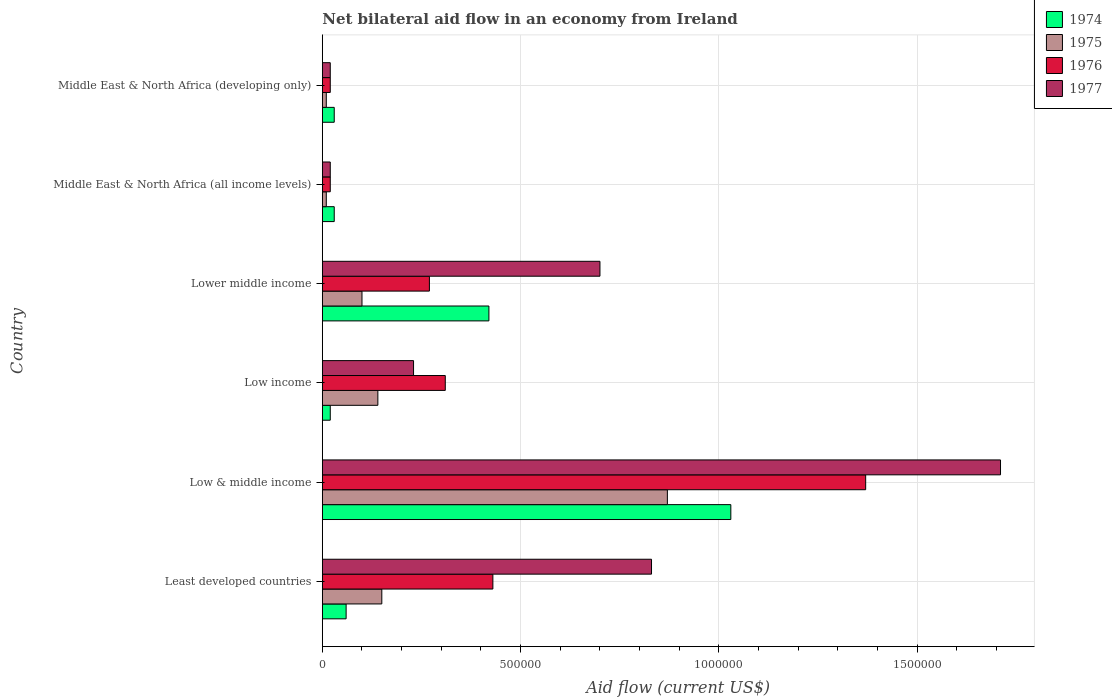How many different coloured bars are there?
Offer a very short reply. 4. How many groups of bars are there?
Make the answer very short. 6. What is the label of the 2nd group of bars from the top?
Offer a very short reply. Middle East & North Africa (all income levels). What is the net bilateral aid flow in 1975 in Lower middle income?
Make the answer very short. 1.00e+05. Across all countries, what is the maximum net bilateral aid flow in 1977?
Keep it short and to the point. 1.71e+06. Across all countries, what is the minimum net bilateral aid flow in 1975?
Your answer should be very brief. 10000. In which country was the net bilateral aid flow in 1975 minimum?
Your answer should be very brief. Middle East & North Africa (all income levels). What is the total net bilateral aid flow in 1977 in the graph?
Your response must be concise. 3.51e+06. What is the difference between the net bilateral aid flow in 1974 in Low income and that in Lower middle income?
Provide a succinct answer. -4.00e+05. What is the average net bilateral aid flow in 1976 per country?
Ensure brevity in your answer.  4.03e+05. Is the net bilateral aid flow in 1975 in Least developed countries less than that in Middle East & North Africa (all income levels)?
Your answer should be compact. No. What is the difference between the highest and the second highest net bilateral aid flow in 1974?
Give a very brief answer. 6.10e+05. What is the difference between the highest and the lowest net bilateral aid flow in 1977?
Provide a succinct answer. 1.69e+06. Is the sum of the net bilateral aid flow in 1975 in Low & middle income and Middle East & North Africa (developing only) greater than the maximum net bilateral aid flow in 1977 across all countries?
Provide a short and direct response. No. Is it the case that in every country, the sum of the net bilateral aid flow in 1976 and net bilateral aid flow in 1977 is greater than the sum of net bilateral aid flow in 1974 and net bilateral aid flow in 1975?
Provide a short and direct response. No. What does the 3rd bar from the top in Lower middle income represents?
Your answer should be compact. 1975. What does the 3rd bar from the bottom in Low income represents?
Your answer should be very brief. 1976. How many bars are there?
Provide a short and direct response. 24. Are all the bars in the graph horizontal?
Make the answer very short. Yes. How many countries are there in the graph?
Your response must be concise. 6. Does the graph contain any zero values?
Offer a terse response. No. Does the graph contain grids?
Ensure brevity in your answer.  Yes. Where does the legend appear in the graph?
Your answer should be compact. Top right. How many legend labels are there?
Keep it short and to the point. 4. What is the title of the graph?
Offer a very short reply. Net bilateral aid flow in an economy from Ireland. Does "2001" appear as one of the legend labels in the graph?
Your answer should be very brief. No. What is the Aid flow (current US$) in 1974 in Least developed countries?
Provide a short and direct response. 6.00e+04. What is the Aid flow (current US$) in 1976 in Least developed countries?
Ensure brevity in your answer.  4.30e+05. What is the Aid flow (current US$) of 1977 in Least developed countries?
Make the answer very short. 8.30e+05. What is the Aid flow (current US$) in 1974 in Low & middle income?
Offer a very short reply. 1.03e+06. What is the Aid flow (current US$) of 1975 in Low & middle income?
Offer a terse response. 8.70e+05. What is the Aid flow (current US$) in 1976 in Low & middle income?
Provide a short and direct response. 1.37e+06. What is the Aid flow (current US$) of 1977 in Low & middle income?
Your answer should be very brief. 1.71e+06. What is the Aid flow (current US$) of 1975 in Low income?
Your answer should be compact. 1.40e+05. What is the Aid flow (current US$) of 1976 in Low income?
Provide a short and direct response. 3.10e+05. What is the Aid flow (current US$) of 1974 in Lower middle income?
Ensure brevity in your answer.  4.20e+05. What is the Aid flow (current US$) in 1975 in Lower middle income?
Provide a short and direct response. 1.00e+05. What is the Aid flow (current US$) of 1976 in Lower middle income?
Your answer should be compact. 2.70e+05. What is the Aid flow (current US$) in 1975 in Middle East & North Africa (all income levels)?
Make the answer very short. 10000. What is the Aid flow (current US$) in 1974 in Middle East & North Africa (developing only)?
Your answer should be very brief. 3.00e+04. What is the Aid flow (current US$) of 1975 in Middle East & North Africa (developing only)?
Make the answer very short. 10000. What is the Aid flow (current US$) of 1976 in Middle East & North Africa (developing only)?
Keep it short and to the point. 2.00e+04. Across all countries, what is the maximum Aid flow (current US$) of 1974?
Keep it short and to the point. 1.03e+06. Across all countries, what is the maximum Aid flow (current US$) of 1975?
Give a very brief answer. 8.70e+05. Across all countries, what is the maximum Aid flow (current US$) in 1976?
Provide a succinct answer. 1.37e+06. Across all countries, what is the maximum Aid flow (current US$) of 1977?
Keep it short and to the point. 1.71e+06. Across all countries, what is the minimum Aid flow (current US$) in 1974?
Keep it short and to the point. 2.00e+04. Across all countries, what is the minimum Aid flow (current US$) of 1975?
Give a very brief answer. 10000. Across all countries, what is the minimum Aid flow (current US$) in 1977?
Your answer should be compact. 2.00e+04. What is the total Aid flow (current US$) of 1974 in the graph?
Offer a very short reply. 1.59e+06. What is the total Aid flow (current US$) in 1975 in the graph?
Offer a very short reply. 1.28e+06. What is the total Aid flow (current US$) in 1976 in the graph?
Make the answer very short. 2.42e+06. What is the total Aid flow (current US$) in 1977 in the graph?
Ensure brevity in your answer.  3.51e+06. What is the difference between the Aid flow (current US$) of 1974 in Least developed countries and that in Low & middle income?
Offer a very short reply. -9.70e+05. What is the difference between the Aid flow (current US$) of 1975 in Least developed countries and that in Low & middle income?
Provide a succinct answer. -7.20e+05. What is the difference between the Aid flow (current US$) in 1976 in Least developed countries and that in Low & middle income?
Provide a succinct answer. -9.40e+05. What is the difference between the Aid flow (current US$) in 1977 in Least developed countries and that in Low & middle income?
Your response must be concise. -8.80e+05. What is the difference between the Aid flow (current US$) in 1974 in Least developed countries and that in Low income?
Offer a terse response. 4.00e+04. What is the difference between the Aid flow (current US$) of 1975 in Least developed countries and that in Low income?
Your answer should be very brief. 10000. What is the difference between the Aid flow (current US$) in 1977 in Least developed countries and that in Low income?
Your response must be concise. 6.00e+05. What is the difference between the Aid flow (current US$) in 1974 in Least developed countries and that in Lower middle income?
Your answer should be compact. -3.60e+05. What is the difference between the Aid flow (current US$) in 1976 in Least developed countries and that in Lower middle income?
Offer a very short reply. 1.60e+05. What is the difference between the Aid flow (current US$) in 1974 in Least developed countries and that in Middle East & North Africa (all income levels)?
Give a very brief answer. 3.00e+04. What is the difference between the Aid flow (current US$) in 1975 in Least developed countries and that in Middle East & North Africa (all income levels)?
Your answer should be very brief. 1.40e+05. What is the difference between the Aid flow (current US$) in 1976 in Least developed countries and that in Middle East & North Africa (all income levels)?
Offer a terse response. 4.10e+05. What is the difference between the Aid flow (current US$) of 1977 in Least developed countries and that in Middle East & North Africa (all income levels)?
Make the answer very short. 8.10e+05. What is the difference between the Aid flow (current US$) in 1974 in Least developed countries and that in Middle East & North Africa (developing only)?
Ensure brevity in your answer.  3.00e+04. What is the difference between the Aid flow (current US$) of 1975 in Least developed countries and that in Middle East & North Africa (developing only)?
Give a very brief answer. 1.40e+05. What is the difference between the Aid flow (current US$) in 1976 in Least developed countries and that in Middle East & North Africa (developing only)?
Provide a succinct answer. 4.10e+05. What is the difference between the Aid flow (current US$) of 1977 in Least developed countries and that in Middle East & North Africa (developing only)?
Give a very brief answer. 8.10e+05. What is the difference between the Aid flow (current US$) of 1974 in Low & middle income and that in Low income?
Your answer should be compact. 1.01e+06. What is the difference between the Aid flow (current US$) in 1975 in Low & middle income and that in Low income?
Make the answer very short. 7.30e+05. What is the difference between the Aid flow (current US$) in 1976 in Low & middle income and that in Low income?
Your response must be concise. 1.06e+06. What is the difference between the Aid flow (current US$) in 1977 in Low & middle income and that in Low income?
Your answer should be very brief. 1.48e+06. What is the difference between the Aid flow (current US$) in 1974 in Low & middle income and that in Lower middle income?
Make the answer very short. 6.10e+05. What is the difference between the Aid flow (current US$) of 1975 in Low & middle income and that in Lower middle income?
Your answer should be very brief. 7.70e+05. What is the difference between the Aid flow (current US$) of 1976 in Low & middle income and that in Lower middle income?
Your answer should be compact. 1.10e+06. What is the difference between the Aid flow (current US$) in 1977 in Low & middle income and that in Lower middle income?
Your answer should be very brief. 1.01e+06. What is the difference between the Aid flow (current US$) in 1974 in Low & middle income and that in Middle East & North Africa (all income levels)?
Provide a succinct answer. 1.00e+06. What is the difference between the Aid flow (current US$) in 1975 in Low & middle income and that in Middle East & North Africa (all income levels)?
Your answer should be very brief. 8.60e+05. What is the difference between the Aid flow (current US$) in 1976 in Low & middle income and that in Middle East & North Africa (all income levels)?
Your answer should be compact. 1.35e+06. What is the difference between the Aid flow (current US$) of 1977 in Low & middle income and that in Middle East & North Africa (all income levels)?
Offer a terse response. 1.69e+06. What is the difference between the Aid flow (current US$) of 1975 in Low & middle income and that in Middle East & North Africa (developing only)?
Your answer should be very brief. 8.60e+05. What is the difference between the Aid flow (current US$) of 1976 in Low & middle income and that in Middle East & North Africa (developing only)?
Your answer should be very brief. 1.35e+06. What is the difference between the Aid flow (current US$) in 1977 in Low & middle income and that in Middle East & North Africa (developing only)?
Offer a terse response. 1.69e+06. What is the difference between the Aid flow (current US$) in 1974 in Low income and that in Lower middle income?
Ensure brevity in your answer.  -4.00e+05. What is the difference between the Aid flow (current US$) of 1977 in Low income and that in Lower middle income?
Make the answer very short. -4.70e+05. What is the difference between the Aid flow (current US$) of 1975 in Low income and that in Middle East & North Africa (all income levels)?
Keep it short and to the point. 1.30e+05. What is the difference between the Aid flow (current US$) in 1976 in Low income and that in Middle East & North Africa (all income levels)?
Your answer should be very brief. 2.90e+05. What is the difference between the Aid flow (current US$) in 1977 in Low income and that in Middle East & North Africa (all income levels)?
Your response must be concise. 2.10e+05. What is the difference between the Aid flow (current US$) in 1974 in Low income and that in Middle East & North Africa (developing only)?
Your response must be concise. -10000. What is the difference between the Aid flow (current US$) of 1975 in Low income and that in Middle East & North Africa (developing only)?
Offer a terse response. 1.30e+05. What is the difference between the Aid flow (current US$) in 1976 in Low income and that in Middle East & North Africa (developing only)?
Ensure brevity in your answer.  2.90e+05. What is the difference between the Aid flow (current US$) in 1977 in Low income and that in Middle East & North Africa (developing only)?
Provide a short and direct response. 2.10e+05. What is the difference between the Aid flow (current US$) in 1974 in Lower middle income and that in Middle East & North Africa (all income levels)?
Your answer should be compact. 3.90e+05. What is the difference between the Aid flow (current US$) in 1975 in Lower middle income and that in Middle East & North Africa (all income levels)?
Keep it short and to the point. 9.00e+04. What is the difference between the Aid flow (current US$) of 1977 in Lower middle income and that in Middle East & North Africa (all income levels)?
Provide a succinct answer. 6.80e+05. What is the difference between the Aid flow (current US$) of 1975 in Lower middle income and that in Middle East & North Africa (developing only)?
Your response must be concise. 9.00e+04. What is the difference between the Aid flow (current US$) of 1976 in Lower middle income and that in Middle East & North Africa (developing only)?
Your response must be concise. 2.50e+05. What is the difference between the Aid flow (current US$) of 1977 in Lower middle income and that in Middle East & North Africa (developing only)?
Your answer should be very brief. 6.80e+05. What is the difference between the Aid flow (current US$) in 1975 in Middle East & North Africa (all income levels) and that in Middle East & North Africa (developing only)?
Your answer should be very brief. 0. What is the difference between the Aid flow (current US$) of 1976 in Middle East & North Africa (all income levels) and that in Middle East & North Africa (developing only)?
Make the answer very short. 0. What is the difference between the Aid flow (current US$) of 1974 in Least developed countries and the Aid flow (current US$) of 1975 in Low & middle income?
Your answer should be very brief. -8.10e+05. What is the difference between the Aid flow (current US$) of 1974 in Least developed countries and the Aid flow (current US$) of 1976 in Low & middle income?
Provide a succinct answer. -1.31e+06. What is the difference between the Aid flow (current US$) in 1974 in Least developed countries and the Aid flow (current US$) in 1977 in Low & middle income?
Provide a short and direct response. -1.65e+06. What is the difference between the Aid flow (current US$) in 1975 in Least developed countries and the Aid flow (current US$) in 1976 in Low & middle income?
Keep it short and to the point. -1.22e+06. What is the difference between the Aid flow (current US$) in 1975 in Least developed countries and the Aid flow (current US$) in 1977 in Low & middle income?
Give a very brief answer. -1.56e+06. What is the difference between the Aid flow (current US$) of 1976 in Least developed countries and the Aid flow (current US$) of 1977 in Low & middle income?
Your answer should be very brief. -1.28e+06. What is the difference between the Aid flow (current US$) of 1974 in Least developed countries and the Aid flow (current US$) of 1975 in Low income?
Give a very brief answer. -8.00e+04. What is the difference between the Aid flow (current US$) in 1974 in Least developed countries and the Aid flow (current US$) in 1976 in Low income?
Offer a very short reply. -2.50e+05. What is the difference between the Aid flow (current US$) of 1974 in Least developed countries and the Aid flow (current US$) of 1977 in Low income?
Provide a succinct answer. -1.70e+05. What is the difference between the Aid flow (current US$) of 1975 in Least developed countries and the Aid flow (current US$) of 1977 in Low income?
Provide a succinct answer. -8.00e+04. What is the difference between the Aid flow (current US$) in 1976 in Least developed countries and the Aid flow (current US$) in 1977 in Low income?
Give a very brief answer. 2.00e+05. What is the difference between the Aid flow (current US$) in 1974 in Least developed countries and the Aid flow (current US$) in 1975 in Lower middle income?
Offer a terse response. -4.00e+04. What is the difference between the Aid flow (current US$) in 1974 in Least developed countries and the Aid flow (current US$) in 1977 in Lower middle income?
Your answer should be very brief. -6.40e+05. What is the difference between the Aid flow (current US$) in 1975 in Least developed countries and the Aid flow (current US$) in 1977 in Lower middle income?
Your response must be concise. -5.50e+05. What is the difference between the Aid flow (current US$) in 1976 in Least developed countries and the Aid flow (current US$) in 1977 in Lower middle income?
Give a very brief answer. -2.70e+05. What is the difference between the Aid flow (current US$) in 1975 in Least developed countries and the Aid flow (current US$) in 1976 in Middle East & North Africa (all income levels)?
Keep it short and to the point. 1.30e+05. What is the difference between the Aid flow (current US$) in 1975 in Least developed countries and the Aid flow (current US$) in 1976 in Middle East & North Africa (developing only)?
Give a very brief answer. 1.30e+05. What is the difference between the Aid flow (current US$) of 1975 in Least developed countries and the Aid flow (current US$) of 1977 in Middle East & North Africa (developing only)?
Your response must be concise. 1.30e+05. What is the difference between the Aid flow (current US$) in 1974 in Low & middle income and the Aid flow (current US$) in 1975 in Low income?
Make the answer very short. 8.90e+05. What is the difference between the Aid flow (current US$) in 1974 in Low & middle income and the Aid flow (current US$) in 1976 in Low income?
Your response must be concise. 7.20e+05. What is the difference between the Aid flow (current US$) of 1975 in Low & middle income and the Aid flow (current US$) of 1976 in Low income?
Your response must be concise. 5.60e+05. What is the difference between the Aid flow (current US$) of 1975 in Low & middle income and the Aid flow (current US$) of 1977 in Low income?
Your response must be concise. 6.40e+05. What is the difference between the Aid flow (current US$) in 1976 in Low & middle income and the Aid flow (current US$) in 1977 in Low income?
Ensure brevity in your answer.  1.14e+06. What is the difference between the Aid flow (current US$) of 1974 in Low & middle income and the Aid flow (current US$) of 1975 in Lower middle income?
Make the answer very short. 9.30e+05. What is the difference between the Aid flow (current US$) of 1974 in Low & middle income and the Aid flow (current US$) of 1976 in Lower middle income?
Your answer should be compact. 7.60e+05. What is the difference between the Aid flow (current US$) of 1975 in Low & middle income and the Aid flow (current US$) of 1976 in Lower middle income?
Provide a short and direct response. 6.00e+05. What is the difference between the Aid flow (current US$) of 1975 in Low & middle income and the Aid flow (current US$) of 1977 in Lower middle income?
Offer a terse response. 1.70e+05. What is the difference between the Aid flow (current US$) in 1976 in Low & middle income and the Aid flow (current US$) in 1977 in Lower middle income?
Your answer should be very brief. 6.70e+05. What is the difference between the Aid flow (current US$) of 1974 in Low & middle income and the Aid flow (current US$) of 1975 in Middle East & North Africa (all income levels)?
Make the answer very short. 1.02e+06. What is the difference between the Aid flow (current US$) in 1974 in Low & middle income and the Aid flow (current US$) in 1976 in Middle East & North Africa (all income levels)?
Provide a succinct answer. 1.01e+06. What is the difference between the Aid flow (current US$) of 1974 in Low & middle income and the Aid flow (current US$) of 1977 in Middle East & North Africa (all income levels)?
Provide a succinct answer. 1.01e+06. What is the difference between the Aid flow (current US$) of 1975 in Low & middle income and the Aid flow (current US$) of 1976 in Middle East & North Africa (all income levels)?
Offer a very short reply. 8.50e+05. What is the difference between the Aid flow (current US$) of 1975 in Low & middle income and the Aid flow (current US$) of 1977 in Middle East & North Africa (all income levels)?
Ensure brevity in your answer.  8.50e+05. What is the difference between the Aid flow (current US$) in 1976 in Low & middle income and the Aid flow (current US$) in 1977 in Middle East & North Africa (all income levels)?
Ensure brevity in your answer.  1.35e+06. What is the difference between the Aid flow (current US$) in 1974 in Low & middle income and the Aid flow (current US$) in 1975 in Middle East & North Africa (developing only)?
Your answer should be very brief. 1.02e+06. What is the difference between the Aid flow (current US$) in 1974 in Low & middle income and the Aid flow (current US$) in 1976 in Middle East & North Africa (developing only)?
Your answer should be compact. 1.01e+06. What is the difference between the Aid flow (current US$) in 1974 in Low & middle income and the Aid flow (current US$) in 1977 in Middle East & North Africa (developing only)?
Ensure brevity in your answer.  1.01e+06. What is the difference between the Aid flow (current US$) in 1975 in Low & middle income and the Aid flow (current US$) in 1976 in Middle East & North Africa (developing only)?
Offer a very short reply. 8.50e+05. What is the difference between the Aid flow (current US$) of 1975 in Low & middle income and the Aid flow (current US$) of 1977 in Middle East & North Africa (developing only)?
Your response must be concise. 8.50e+05. What is the difference between the Aid flow (current US$) of 1976 in Low & middle income and the Aid flow (current US$) of 1977 in Middle East & North Africa (developing only)?
Offer a very short reply. 1.35e+06. What is the difference between the Aid flow (current US$) of 1974 in Low income and the Aid flow (current US$) of 1975 in Lower middle income?
Your response must be concise. -8.00e+04. What is the difference between the Aid flow (current US$) in 1974 in Low income and the Aid flow (current US$) in 1977 in Lower middle income?
Make the answer very short. -6.80e+05. What is the difference between the Aid flow (current US$) in 1975 in Low income and the Aid flow (current US$) in 1977 in Lower middle income?
Give a very brief answer. -5.60e+05. What is the difference between the Aid flow (current US$) of 1976 in Low income and the Aid flow (current US$) of 1977 in Lower middle income?
Your response must be concise. -3.90e+05. What is the difference between the Aid flow (current US$) in 1974 in Low income and the Aid flow (current US$) in 1977 in Middle East & North Africa (all income levels)?
Offer a terse response. 0. What is the difference between the Aid flow (current US$) in 1975 in Low income and the Aid flow (current US$) in 1977 in Middle East & North Africa (all income levels)?
Give a very brief answer. 1.20e+05. What is the difference between the Aid flow (current US$) of 1976 in Low income and the Aid flow (current US$) of 1977 in Middle East & North Africa (all income levels)?
Your answer should be compact. 2.90e+05. What is the difference between the Aid flow (current US$) of 1974 in Low income and the Aid flow (current US$) of 1975 in Middle East & North Africa (developing only)?
Provide a succinct answer. 10000. What is the difference between the Aid flow (current US$) in 1974 in Low income and the Aid flow (current US$) in 1977 in Middle East & North Africa (developing only)?
Ensure brevity in your answer.  0. What is the difference between the Aid flow (current US$) in 1975 in Low income and the Aid flow (current US$) in 1976 in Middle East & North Africa (developing only)?
Ensure brevity in your answer.  1.20e+05. What is the difference between the Aid flow (current US$) of 1975 in Low income and the Aid flow (current US$) of 1977 in Middle East & North Africa (developing only)?
Ensure brevity in your answer.  1.20e+05. What is the difference between the Aid flow (current US$) of 1974 in Lower middle income and the Aid flow (current US$) of 1975 in Middle East & North Africa (all income levels)?
Offer a terse response. 4.10e+05. What is the difference between the Aid flow (current US$) in 1975 in Lower middle income and the Aid flow (current US$) in 1977 in Middle East & North Africa (all income levels)?
Your answer should be compact. 8.00e+04. What is the difference between the Aid flow (current US$) in 1974 in Lower middle income and the Aid flow (current US$) in 1976 in Middle East & North Africa (developing only)?
Provide a short and direct response. 4.00e+05. What is the difference between the Aid flow (current US$) of 1974 in Lower middle income and the Aid flow (current US$) of 1977 in Middle East & North Africa (developing only)?
Ensure brevity in your answer.  4.00e+05. What is the difference between the Aid flow (current US$) of 1975 in Lower middle income and the Aid flow (current US$) of 1977 in Middle East & North Africa (developing only)?
Your answer should be very brief. 8.00e+04. What is the difference between the Aid flow (current US$) of 1974 in Middle East & North Africa (all income levels) and the Aid flow (current US$) of 1975 in Middle East & North Africa (developing only)?
Your answer should be compact. 2.00e+04. What is the difference between the Aid flow (current US$) of 1974 in Middle East & North Africa (all income levels) and the Aid flow (current US$) of 1977 in Middle East & North Africa (developing only)?
Offer a very short reply. 10000. What is the difference between the Aid flow (current US$) in 1976 in Middle East & North Africa (all income levels) and the Aid flow (current US$) in 1977 in Middle East & North Africa (developing only)?
Give a very brief answer. 0. What is the average Aid flow (current US$) of 1974 per country?
Offer a very short reply. 2.65e+05. What is the average Aid flow (current US$) of 1975 per country?
Your answer should be very brief. 2.13e+05. What is the average Aid flow (current US$) in 1976 per country?
Ensure brevity in your answer.  4.03e+05. What is the average Aid flow (current US$) in 1977 per country?
Offer a terse response. 5.85e+05. What is the difference between the Aid flow (current US$) in 1974 and Aid flow (current US$) in 1975 in Least developed countries?
Your response must be concise. -9.00e+04. What is the difference between the Aid flow (current US$) in 1974 and Aid flow (current US$) in 1976 in Least developed countries?
Give a very brief answer. -3.70e+05. What is the difference between the Aid flow (current US$) in 1974 and Aid flow (current US$) in 1977 in Least developed countries?
Provide a short and direct response. -7.70e+05. What is the difference between the Aid flow (current US$) of 1975 and Aid flow (current US$) of 1976 in Least developed countries?
Give a very brief answer. -2.80e+05. What is the difference between the Aid flow (current US$) of 1975 and Aid flow (current US$) of 1977 in Least developed countries?
Provide a succinct answer. -6.80e+05. What is the difference between the Aid flow (current US$) of 1976 and Aid flow (current US$) of 1977 in Least developed countries?
Keep it short and to the point. -4.00e+05. What is the difference between the Aid flow (current US$) in 1974 and Aid flow (current US$) in 1975 in Low & middle income?
Give a very brief answer. 1.60e+05. What is the difference between the Aid flow (current US$) of 1974 and Aid flow (current US$) of 1977 in Low & middle income?
Your response must be concise. -6.80e+05. What is the difference between the Aid flow (current US$) of 1975 and Aid flow (current US$) of 1976 in Low & middle income?
Keep it short and to the point. -5.00e+05. What is the difference between the Aid flow (current US$) of 1975 and Aid flow (current US$) of 1977 in Low & middle income?
Keep it short and to the point. -8.40e+05. What is the difference between the Aid flow (current US$) of 1974 and Aid flow (current US$) of 1975 in Low income?
Offer a very short reply. -1.20e+05. What is the difference between the Aid flow (current US$) of 1974 and Aid flow (current US$) of 1977 in Low income?
Offer a terse response. -2.10e+05. What is the difference between the Aid flow (current US$) in 1975 and Aid flow (current US$) in 1976 in Low income?
Offer a very short reply. -1.70e+05. What is the difference between the Aid flow (current US$) of 1975 and Aid flow (current US$) of 1977 in Low income?
Offer a terse response. -9.00e+04. What is the difference between the Aid flow (current US$) in 1976 and Aid flow (current US$) in 1977 in Low income?
Provide a short and direct response. 8.00e+04. What is the difference between the Aid flow (current US$) in 1974 and Aid flow (current US$) in 1975 in Lower middle income?
Ensure brevity in your answer.  3.20e+05. What is the difference between the Aid flow (current US$) of 1974 and Aid flow (current US$) of 1976 in Lower middle income?
Ensure brevity in your answer.  1.50e+05. What is the difference between the Aid flow (current US$) of 1974 and Aid flow (current US$) of 1977 in Lower middle income?
Offer a terse response. -2.80e+05. What is the difference between the Aid flow (current US$) of 1975 and Aid flow (current US$) of 1977 in Lower middle income?
Ensure brevity in your answer.  -6.00e+05. What is the difference between the Aid flow (current US$) of 1976 and Aid flow (current US$) of 1977 in Lower middle income?
Your answer should be very brief. -4.30e+05. What is the ratio of the Aid flow (current US$) of 1974 in Least developed countries to that in Low & middle income?
Keep it short and to the point. 0.06. What is the ratio of the Aid flow (current US$) of 1975 in Least developed countries to that in Low & middle income?
Keep it short and to the point. 0.17. What is the ratio of the Aid flow (current US$) in 1976 in Least developed countries to that in Low & middle income?
Offer a terse response. 0.31. What is the ratio of the Aid flow (current US$) in 1977 in Least developed countries to that in Low & middle income?
Offer a terse response. 0.49. What is the ratio of the Aid flow (current US$) in 1974 in Least developed countries to that in Low income?
Give a very brief answer. 3. What is the ratio of the Aid flow (current US$) in 1975 in Least developed countries to that in Low income?
Provide a succinct answer. 1.07. What is the ratio of the Aid flow (current US$) of 1976 in Least developed countries to that in Low income?
Give a very brief answer. 1.39. What is the ratio of the Aid flow (current US$) of 1977 in Least developed countries to that in Low income?
Ensure brevity in your answer.  3.61. What is the ratio of the Aid flow (current US$) in 1974 in Least developed countries to that in Lower middle income?
Offer a terse response. 0.14. What is the ratio of the Aid flow (current US$) of 1975 in Least developed countries to that in Lower middle income?
Provide a succinct answer. 1.5. What is the ratio of the Aid flow (current US$) of 1976 in Least developed countries to that in Lower middle income?
Offer a very short reply. 1.59. What is the ratio of the Aid flow (current US$) of 1977 in Least developed countries to that in Lower middle income?
Offer a terse response. 1.19. What is the ratio of the Aid flow (current US$) of 1975 in Least developed countries to that in Middle East & North Africa (all income levels)?
Offer a terse response. 15. What is the ratio of the Aid flow (current US$) of 1977 in Least developed countries to that in Middle East & North Africa (all income levels)?
Your answer should be very brief. 41.5. What is the ratio of the Aid flow (current US$) of 1976 in Least developed countries to that in Middle East & North Africa (developing only)?
Offer a terse response. 21.5. What is the ratio of the Aid flow (current US$) of 1977 in Least developed countries to that in Middle East & North Africa (developing only)?
Give a very brief answer. 41.5. What is the ratio of the Aid flow (current US$) of 1974 in Low & middle income to that in Low income?
Make the answer very short. 51.5. What is the ratio of the Aid flow (current US$) of 1975 in Low & middle income to that in Low income?
Make the answer very short. 6.21. What is the ratio of the Aid flow (current US$) in 1976 in Low & middle income to that in Low income?
Give a very brief answer. 4.42. What is the ratio of the Aid flow (current US$) in 1977 in Low & middle income to that in Low income?
Keep it short and to the point. 7.43. What is the ratio of the Aid flow (current US$) in 1974 in Low & middle income to that in Lower middle income?
Give a very brief answer. 2.45. What is the ratio of the Aid flow (current US$) of 1976 in Low & middle income to that in Lower middle income?
Keep it short and to the point. 5.07. What is the ratio of the Aid flow (current US$) of 1977 in Low & middle income to that in Lower middle income?
Give a very brief answer. 2.44. What is the ratio of the Aid flow (current US$) in 1974 in Low & middle income to that in Middle East & North Africa (all income levels)?
Offer a terse response. 34.33. What is the ratio of the Aid flow (current US$) in 1976 in Low & middle income to that in Middle East & North Africa (all income levels)?
Keep it short and to the point. 68.5. What is the ratio of the Aid flow (current US$) in 1977 in Low & middle income to that in Middle East & North Africa (all income levels)?
Your response must be concise. 85.5. What is the ratio of the Aid flow (current US$) in 1974 in Low & middle income to that in Middle East & North Africa (developing only)?
Make the answer very short. 34.33. What is the ratio of the Aid flow (current US$) in 1975 in Low & middle income to that in Middle East & North Africa (developing only)?
Your response must be concise. 87. What is the ratio of the Aid flow (current US$) in 1976 in Low & middle income to that in Middle East & North Africa (developing only)?
Ensure brevity in your answer.  68.5. What is the ratio of the Aid flow (current US$) in 1977 in Low & middle income to that in Middle East & North Africa (developing only)?
Ensure brevity in your answer.  85.5. What is the ratio of the Aid flow (current US$) of 1974 in Low income to that in Lower middle income?
Give a very brief answer. 0.05. What is the ratio of the Aid flow (current US$) in 1975 in Low income to that in Lower middle income?
Offer a very short reply. 1.4. What is the ratio of the Aid flow (current US$) of 1976 in Low income to that in Lower middle income?
Offer a terse response. 1.15. What is the ratio of the Aid flow (current US$) of 1977 in Low income to that in Lower middle income?
Your answer should be compact. 0.33. What is the ratio of the Aid flow (current US$) in 1975 in Low income to that in Middle East & North Africa (all income levels)?
Keep it short and to the point. 14. What is the ratio of the Aid flow (current US$) of 1977 in Low income to that in Middle East & North Africa (developing only)?
Ensure brevity in your answer.  11.5. What is the ratio of the Aid flow (current US$) of 1974 in Lower middle income to that in Middle East & North Africa (all income levels)?
Give a very brief answer. 14. What is the ratio of the Aid flow (current US$) of 1975 in Lower middle income to that in Middle East & North Africa (all income levels)?
Make the answer very short. 10. What is the ratio of the Aid flow (current US$) in 1974 in Lower middle income to that in Middle East & North Africa (developing only)?
Offer a terse response. 14. What is the ratio of the Aid flow (current US$) in 1975 in Middle East & North Africa (all income levels) to that in Middle East & North Africa (developing only)?
Your response must be concise. 1. What is the ratio of the Aid flow (current US$) of 1976 in Middle East & North Africa (all income levels) to that in Middle East & North Africa (developing only)?
Provide a succinct answer. 1. What is the difference between the highest and the second highest Aid flow (current US$) of 1974?
Your answer should be very brief. 6.10e+05. What is the difference between the highest and the second highest Aid flow (current US$) in 1975?
Offer a terse response. 7.20e+05. What is the difference between the highest and the second highest Aid flow (current US$) of 1976?
Provide a short and direct response. 9.40e+05. What is the difference between the highest and the second highest Aid flow (current US$) of 1977?
Keep it short and to the point. 8.80e+05. What is the difference between the highest and the lowest Aid flow (current US$) of 1974?
Your answer should be very brief. 1.01e+06. What is the difference between the highest and the lowest Aid flow (current US$) of 1975?
Your answer should be very brief. 8.60e+05. What is the difference between the highest and the lowest Aid flow (current US$) of 1976?
Provide a succinct answer. 1.35e+06. What is the difference between the highest and the lowest Aid flow (current US$) of 1977?
Give a very brief answer. 1.69e+06. 